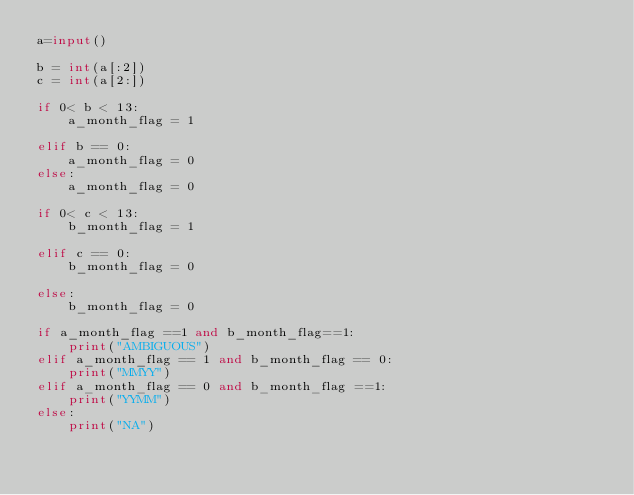<code> <loc_0><loc_0><loc_500><loc_500><_Python_>a=input()
 
b = int(a[:2])
c = int(a[2:])
 
if 0< b < 13:
    a_month_flag = 1
    
elif b == 0:
    a_month_flag = 0    
else:
    a_month_flag = 0
 
if 0< c < 13:
    b_month_flag = 1
    
elif c == 0:
    b_month_flag = 0
  
else:
    b_month_flag = 0
 
if a_month_flag ==1 and b_month_flag==1:
    print("AMBIGUOUS")
elif a_month_flag == 1 and b_month_flag == 0:
    print("MMYY")
elif a_month_flag == 0 and b_month_flag ==1:
    print("YYMM")
else:
    print("NA")</code> 